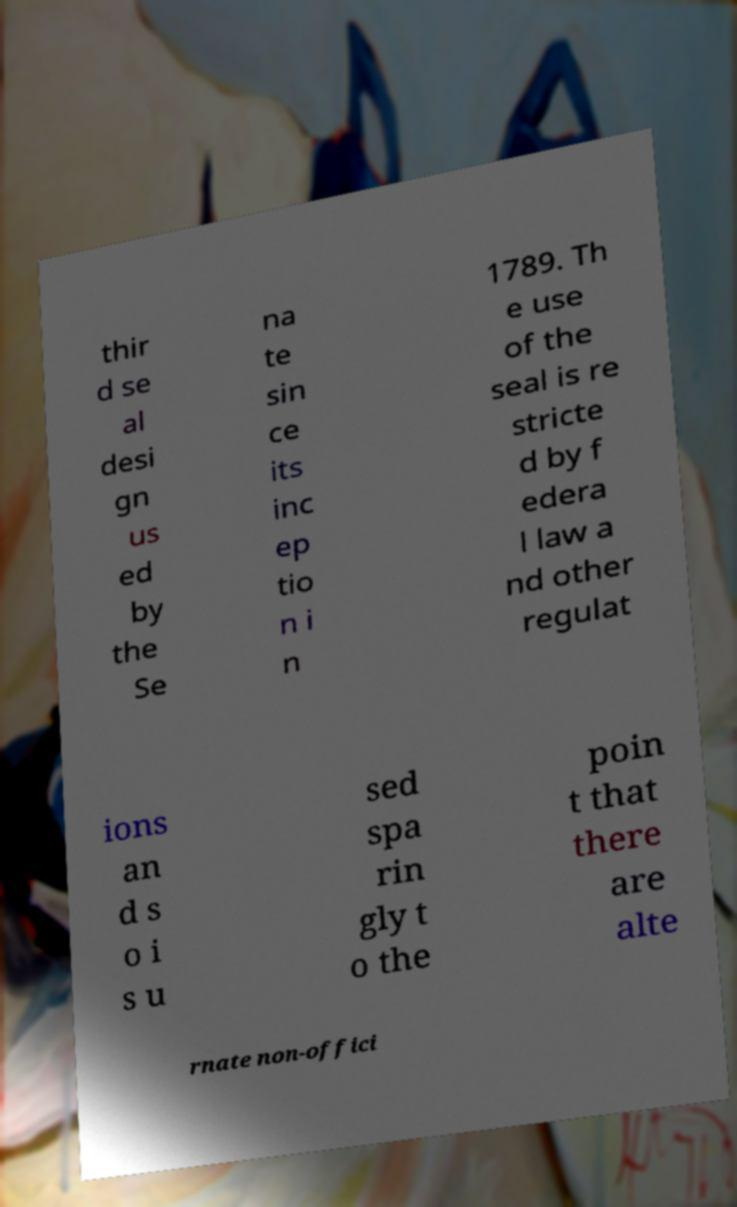I need the written content from this picture converted into text. Can you do that? thir d se al desi gn us ed by the Se na te sin ce its inc ep tio n i n 1789. Th e use of the seal is re stricte d by f edera l law a nd other regulat ions an d s o i s u sed spa rin gly t o the poin t that there are alte rnate non-offici 